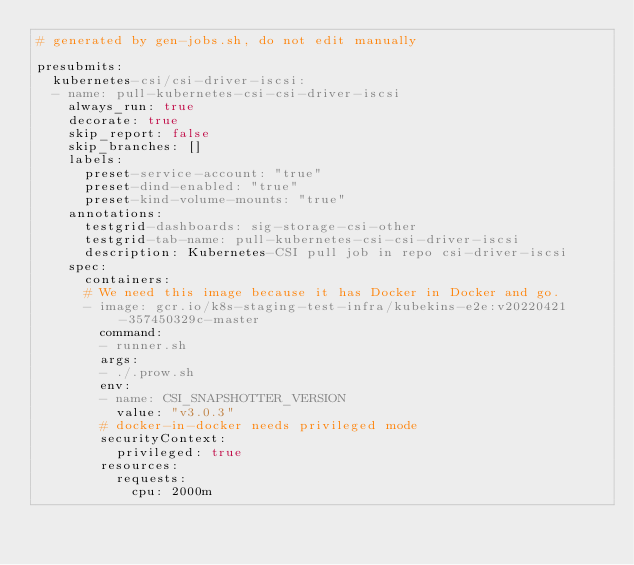<code> <loc_0><loc_0><loc_500><loc_500><_YAML_># generated by gen-jobs.sh, do not edit manually

presubmits:
  kubernetes-csi/csi-driver-iscsi:
  - name: pull-kubernetes-csi-csi-driver-iscsi
    always_run: true
    decorate: true
    skip_report: false
    skip_branches: []
    labels:
      preset-service-account: "true"
      preset-dind-enabled: "true"
      preset-kind-volume-mounts: "true"
    annotations:
      testgrid-dashboards: sig-storage-csi-other
      testgrid-tab-name: pull-kubernetes-csi-csi-driver-iscsi
      description: Kubernetes-CSI pull job in repo csi-driver-iscsi
    spec:
      containers:
      # We need this image because it has Docker in Docker and go.
      - image: gcr.io/k8s-staging-test-infra/kubekins-e2e:v20220421-357450329c-master
        command:
        - runner.sh
        args:
        - ./.prow.sh
        env:
        - name: CSI_SNAPSHOTTER_VERSION
          value: "v3.0.3"
        # docker-in-docker needs privileged mode
        securityContext:
          privileged: true
        resources:
          requests:
            cpu: 2000m
</code> 